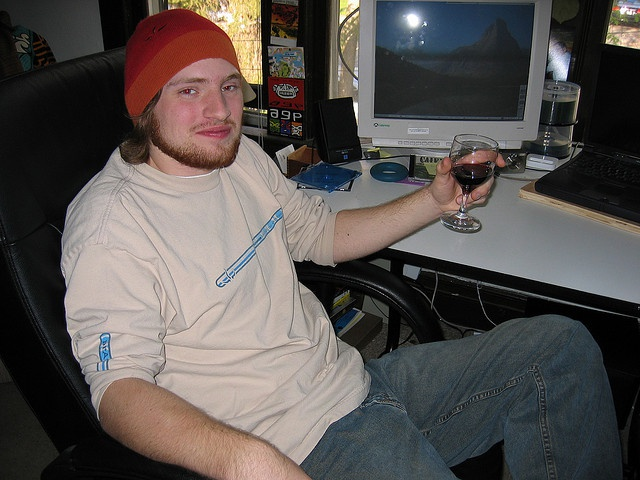Describe the objects in this image and their specific colors. I can see people in black, darkgray, and gray tones, chair in black, maroon, and gray tones, tv in black, gray, and blue tones, laptop in black and gray tones, and wine glass in black and gray tones in this image. 